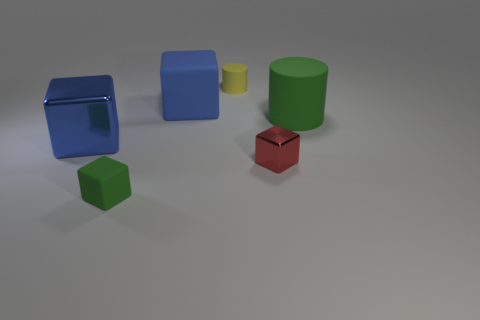How many blue rubber blocks have the same size as the red shiny object?
Provide a short and direct response. 0. What is the size of the object that is the same color as the large rubber cube?
Your answer should be very brief. Large. Is there a thing that has the same color as the small rubber cylinder?
Offer a terse response. No. There is another block that is the same size as the green block; what is its color?
Ensure brevity in your answer.  Red. Do the tiny cylinder and the large rubber thing that is left of the red thing have the same color?
Your response must be concise. No. What is the color of the large rubber block?
Your response must be concise. Blue. There is a cylinder that is on the left side of the red metal block; what is it made of?
Make the answer very short. Rubber. The other metal object that is the same shape as the red object is what size?
Offer a terse response. Large. Are there fewer large objects to the left of the small yellow rubber cylinder than cyan metallic objects?
Your answer should be compact. No. Are any yellow rubber objects visible?
Make the answer very short. Yes. 